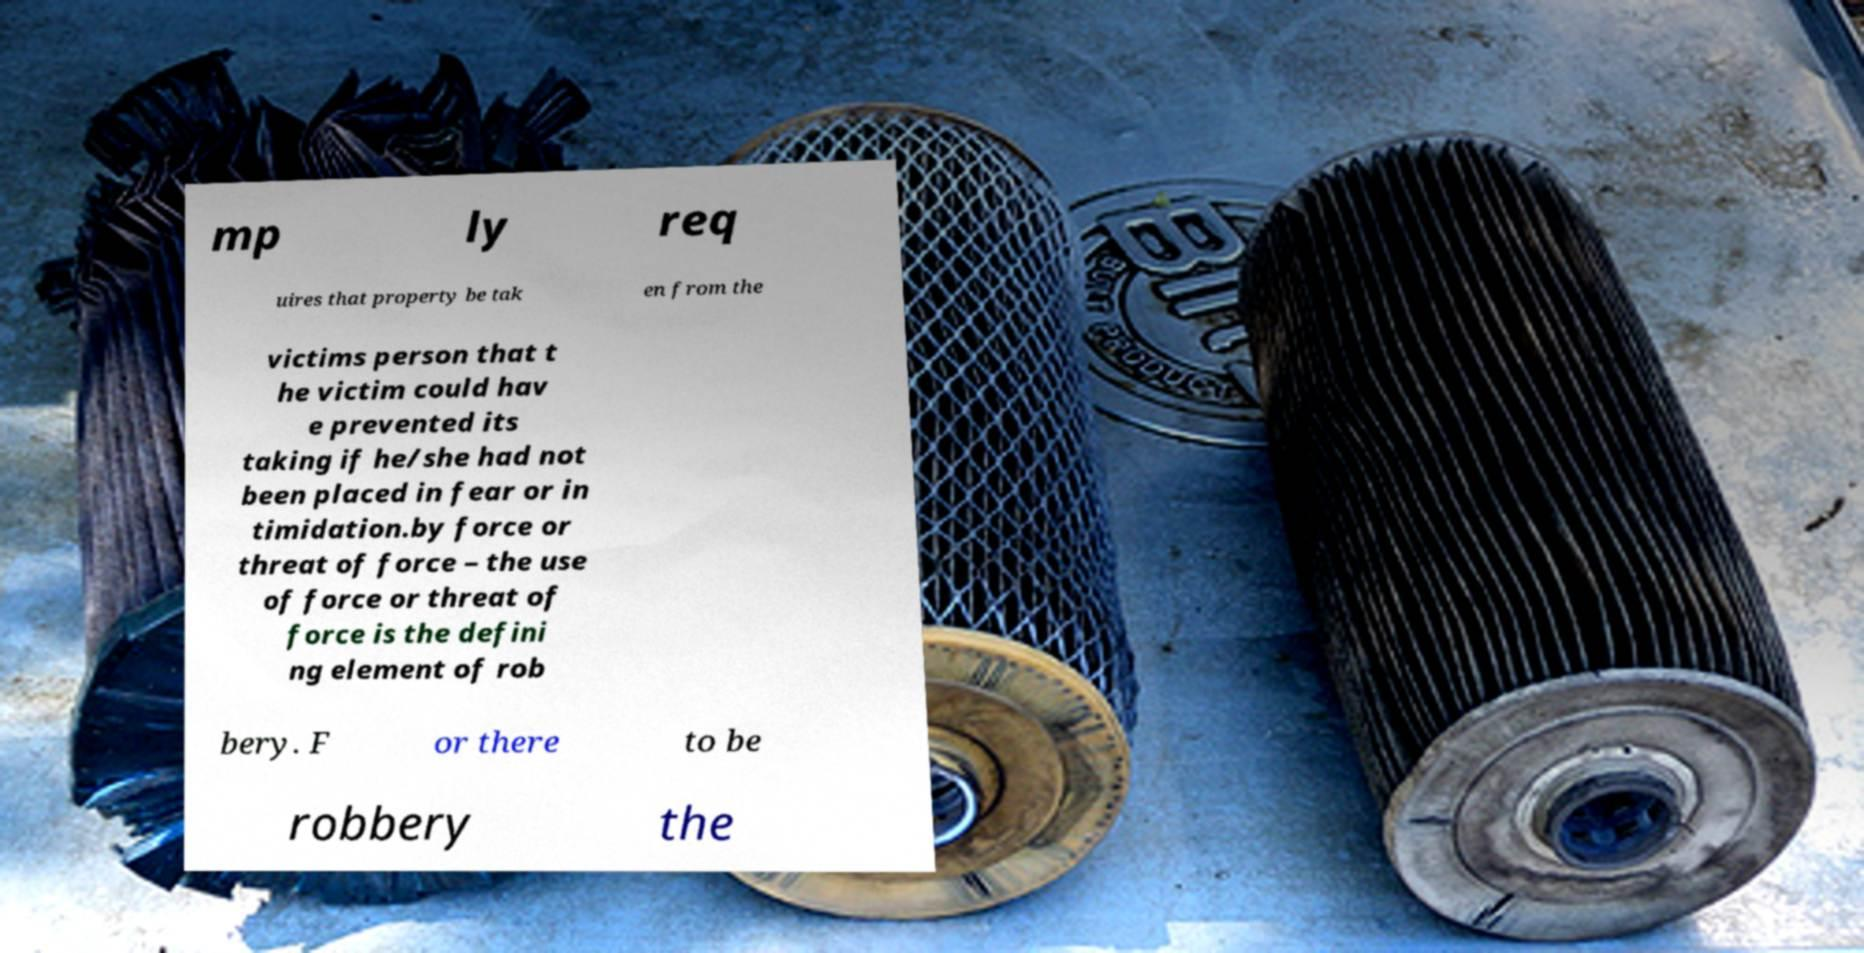What messages or text are displayed in this image? I need them in a readable, typed format. mp ly req uires that property be tak en from the victims person that t he victim could hav e prevented its taking if he/she had not been placed in fear or in timidation.by force or threat of force – the use of force or threat of force is the defini ng element of rob bery. F or there to be robbery the 